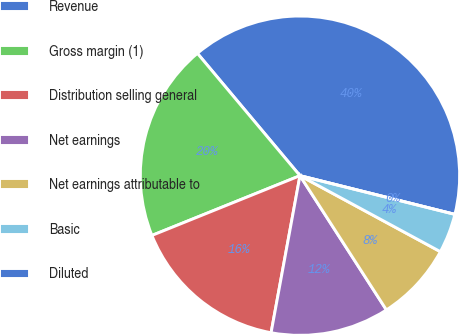<chart> <loc_0><loc_0><loc_500><loc_500><pie_chart><fcel>Revenue<fcel>Gross margin (1)<fcel>Distribution selling general<fcel>Net earnings<fcel>Net earnings attributable to<fcel>Basic<fcel>Diluted<nl><fcel>40.0%<fcel>20.0%<fcel>16.0%<fcel>12.0%<fcel>8.0%<fcel>4.0%<fcel>0.0%<nl></chart> 